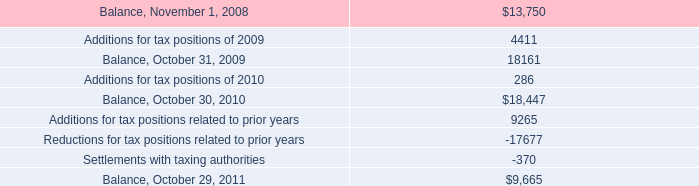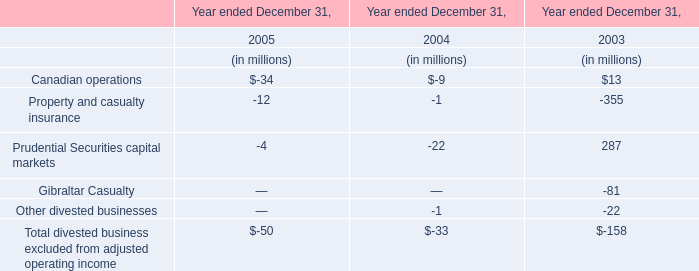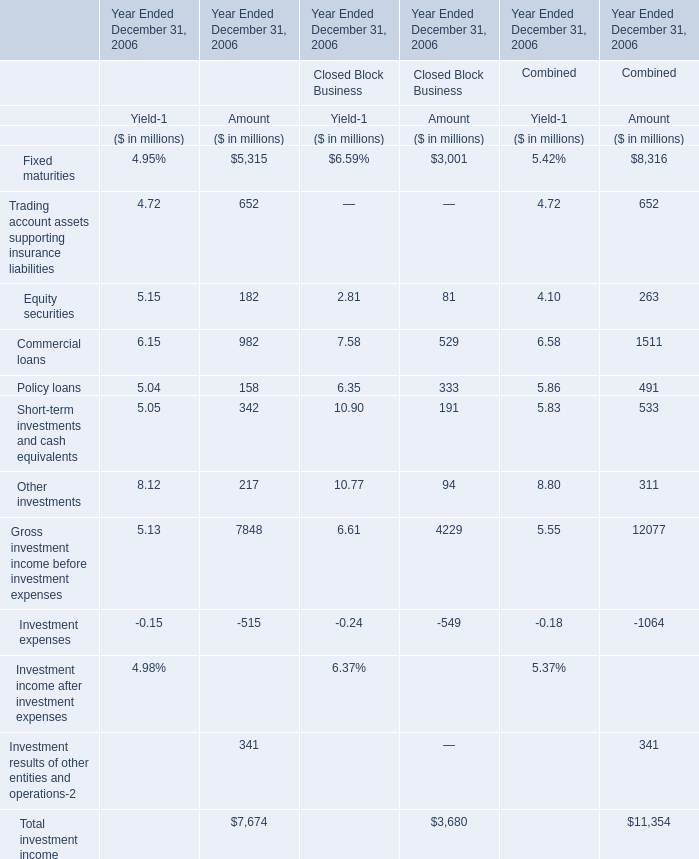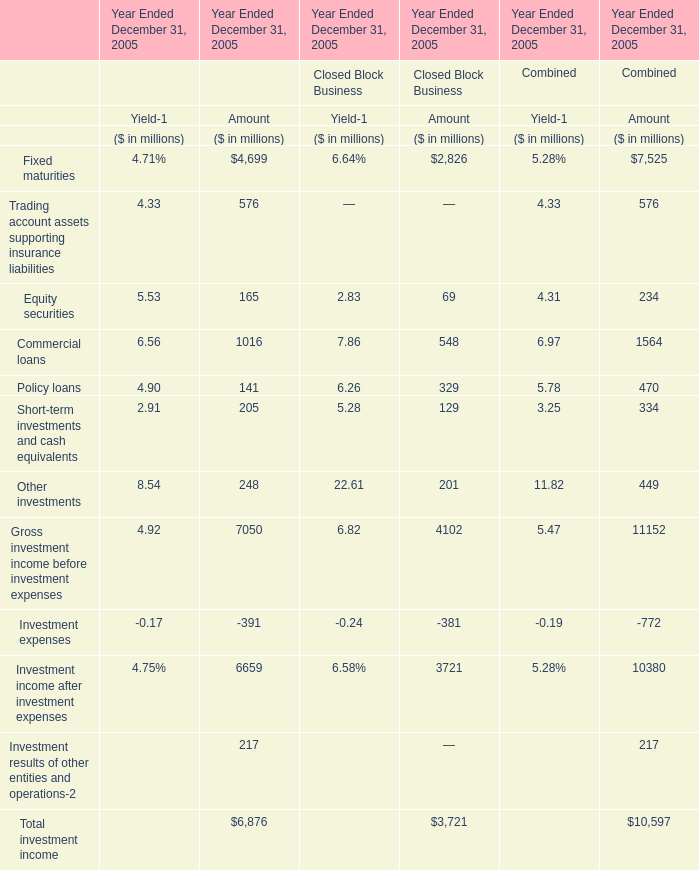What's the sum of all elements that are greater than 300 for Amount of Closed Block Business? (in million) 
Computations: ((3001 + 529) + 333)
Answer: 3863.0. 